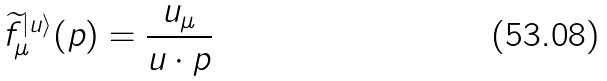Convert formula to latex. <formula><loc_0><loc_0><loc_500><loc_500>\widetilde { f } ^ { | u \rangle } _ { \mu } ( p ) = \frac { u _ { \mu } } { u \cdot p }</formula> 